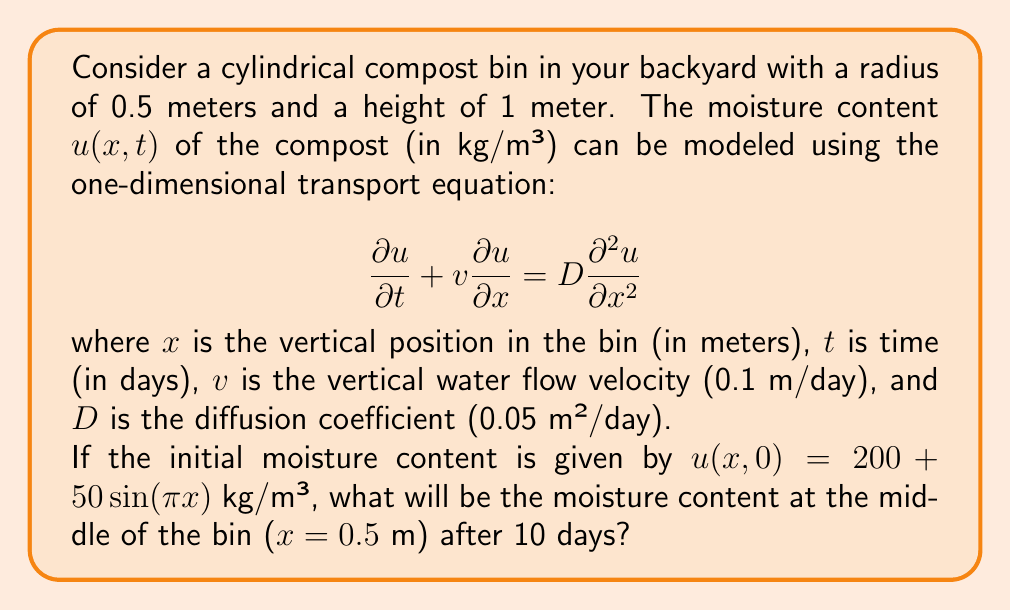Teach me how to tackle this problem. To solve this problem, we need to use the analytical solution of the one-dimensional transport equation with an initial condition. The general solution is given by:

$$u(x,t) = \int_{-\infty}^{\infty} G(x-y,t) u(y,0) dy$$

where $G(x,t)$ is the Green's function:

$$G(x,t) = \frac{1}{\sqrt{4\pi Dt}} \exp\left(-\frac{(x-vt)^2}{4Dt}\right)$$

Given the initial condition $u(x,0) = 200 + 50\sin(\pi x)$, we can substitute this into the general solution:

$$u(x,t) = \int_{0}^{1} \frac{1}{\sqrt{4\pi Dt}} \exp\left(-\frac{(x-y-vt)^2}{4Dt}\right) [200 + 50\sin(\pi y)] dy$$

To evaluate this integral, we can separate it into two parts:

1. Constant term:
   $$200 \int_{0}^{1} \frac{1}{\sqrt{4\pi Dt}} \exp\left(-\frac{(x-y-vt)^2}{4Dt}\right) dy$$

2. Sinusoidal term:
   $$50 \int_{0}^{1} \frac{1}{\sqrt{4\pi Dt}} \exp\left(-\frac{(x-y-vt)^2}{4Dt}\right) \sin(\pi y) dy$$

The constant term can be evaluated analytically, while the sinusoidal term requires numerical integration.

For $x = 0.5$ m and $t = 10$ days:

Constant term:
$$200 \left[\text{erf}\left(\frac{0.5-vt}{2\sqrt{Dt}}\right) - \text{erf}\left(\frac{-0.5-vt}{2\sqrt{Dt}}\right)\right]$$

Substituting the values:
$$200 \left[\text{erf}\left(\frac{0.5-1}{2\sqrt{0.05 \cdot 10}}\right) - \text{erf}\left(\frac{-0.5-1}{2\sqrt{0.05 \cdot 10}}\right)\right] \approx 199.98$$

The sinusoidal term can be evaluated numerically, which gives approximately -0.02.

Adding these two terms together, we get the final result:

$$u(0.5, 10) \approx 199.98 - 0.02 = 199.96 \text{ kg/m³}$$
Answer: The moisture content at the middle of the bin ($x = 0.5$ m) after 10 days will be approximately 199.96 kg/m³. 